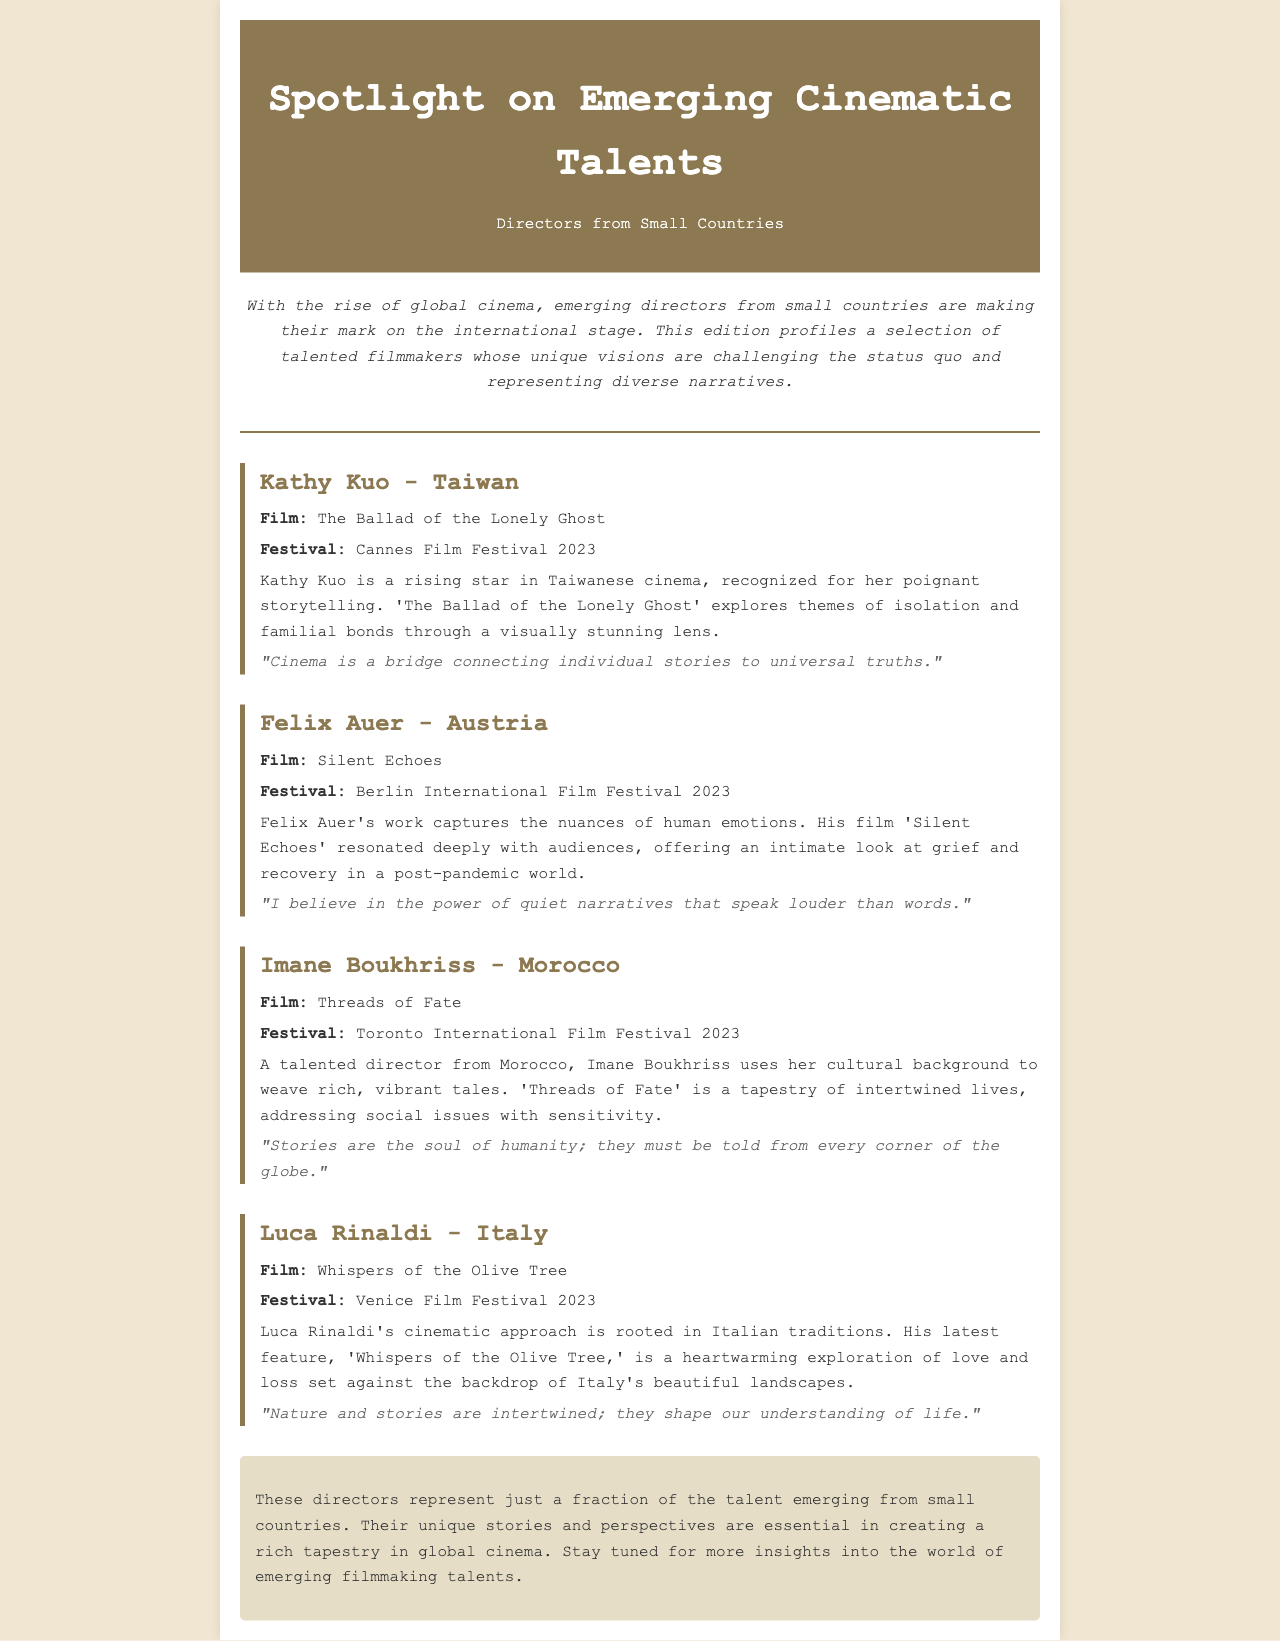What is the title of Kathy Kuo's film? The film made by Kathy Kuo is titled "The Ballad of the Lonely Ghost."
Answer: The Ballad of the Lonely Ghost Which festival did Felix Auer's film premier at? Felix Auer's film "Silent Echoes" was featured at the Berlin International Film Festival 2023.
Answer: Berlin International Film Festival 2023 What theme does Imane Boukhriss's film address? Imane Boukhriss's film "Threads of Fate" addresses social issues with sensitivity.
Answer: Social issues What country is Luca Rinaldi from? Luca Rinaldi is a director from Italy.
Answer: Italy What is the unique vision of emerging directors highlighted in this newsletter? The newsletter emphasizes that these directors have unique visions that challenge the status quo.
Answer: Unique visions What common trait is shared by all directors featured? All directors are from small countries.
Answer: Small countries How many directors are profiled in the newsletter? The newsletter profiles four directors.
Answer: Four What film by Kathy Kuo explores themes of familial bonds? The film by Kathy Kuo that explores familial bonds is "The Ballad of the Lonely Ghost."
Answer: The Ballad of the Lonely Ghost What does Luca Rinaldi believe about nature and stories? Luca Rinaldi believes that nature and stories are intertwined.
Answer: Intertwined 